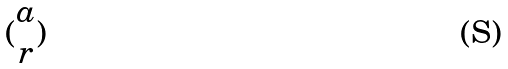<formula> <loc_0><loc_0><loc_500><loc_500>( \begin{matrix} a \\ r \end{matrix} )</formula> 